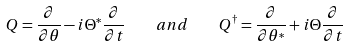Convert formula to latex. <formula><loc_0><loc_0><loc_500><loc_500>Q = { \frac { \partial } { \partial \theta } } - i \Theta ^ { * } { \frac { \partial } { \partial t } } \quad a n d \quad Q ^ { \dagger } = { \frac { \partial } { \partial \theta ^ { * } } } + i \Theta { \frac { \partial } { \partial t } }</formula> 